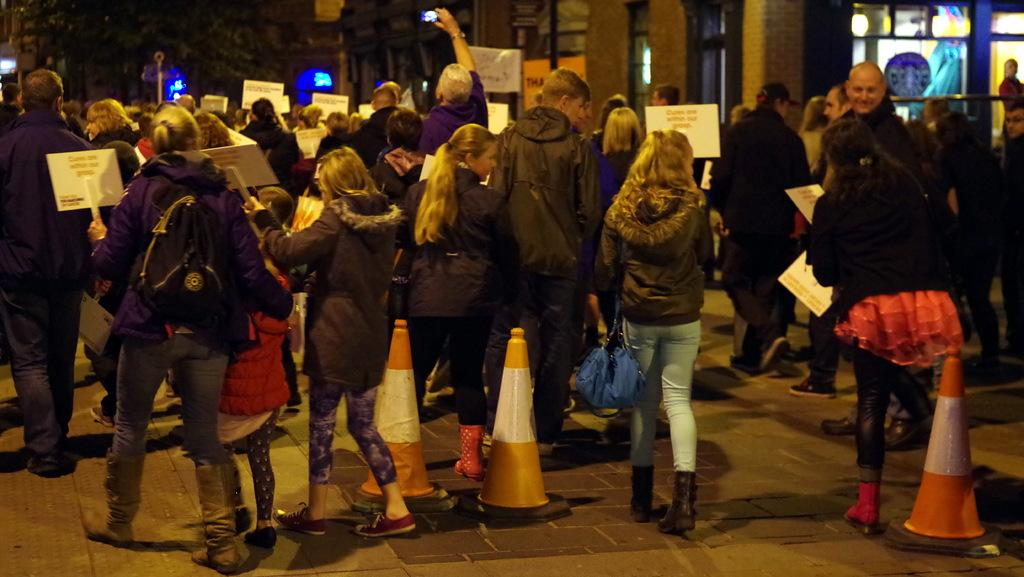How many people are present in the image? There are many people in the image. What are the people in the image doing? The people are walking, holding bags, holding cards, and taking pictures. What can be seen in the background of the image? There is a building visible in the image. What type of waste can be seen on the floor in the image? There is no waste or floor mentioned in the image; it focuses on people walking, holding bags, holding cards, and taking pictures. 